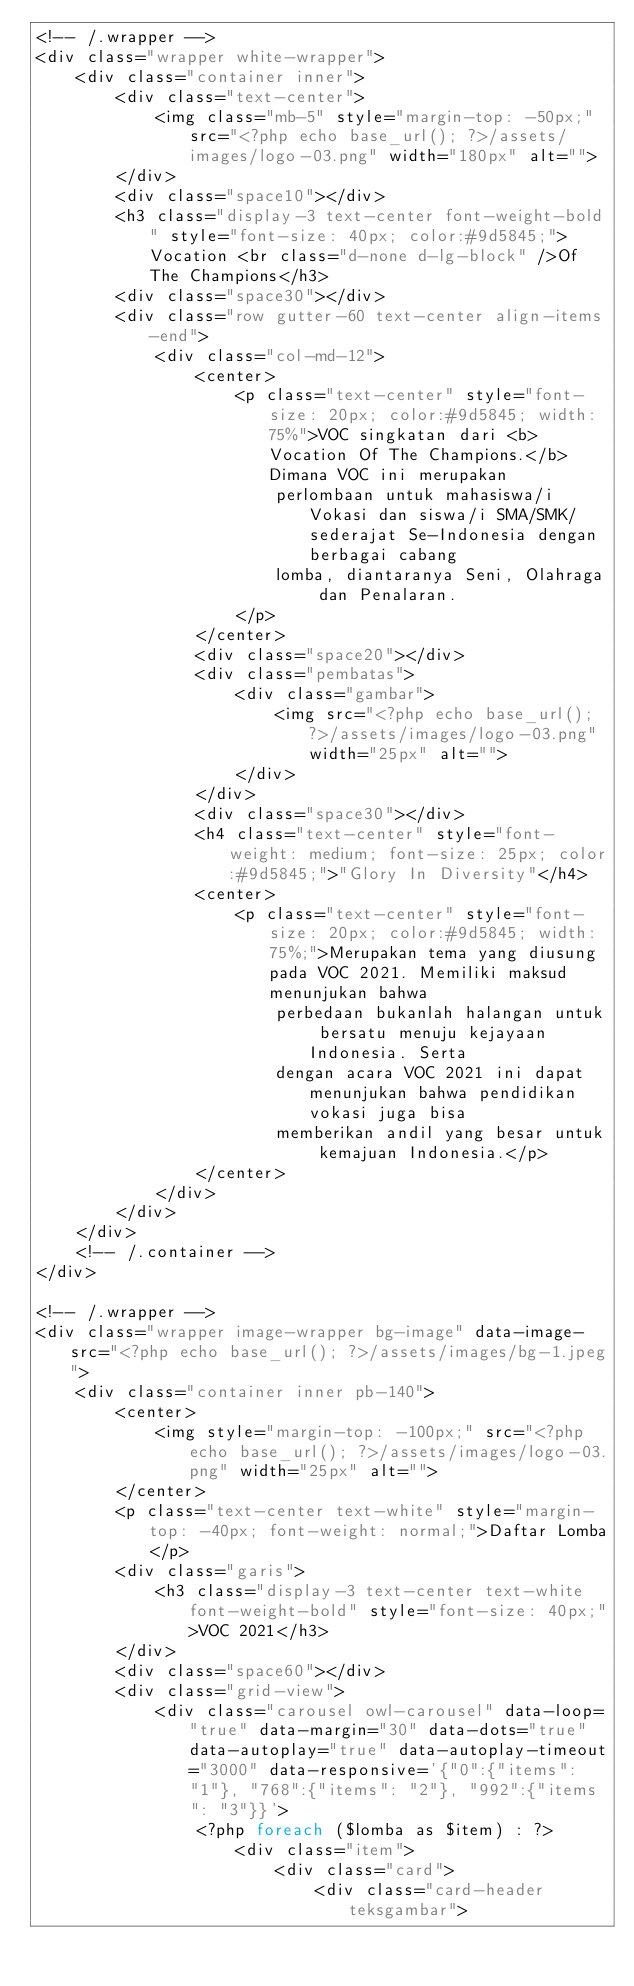<code> <loc_0><loc_0><loc_500><loc_500><_PHP_><!-- /.wrapper -->
<div class="wrapper white-wrapper">
	<div class="container inner">
		<div class="text-center">
			<img class="mb-5" style="margin-top: -50px;" src="<?php echo base_url(); ?>/assets/images/logo-03.png" width="180px" alt="">
		</div>
		<div class="space10"></div>
		<h3 class="display-3 text-center font-weight-bold" style="font-size: 40px; color:#9d5845;">Vocation <br class="d-none d-lg-block" />Of The Champions</h3>
		<div class="space30"></div>
		<div class="row gutter-60 text-center align-items-end">
			<div class="col-md-12">
				<center>
					<p class="text-center" style="font-size: 20px; color:#9d5845; width: 75%">VOC singkatan dari <b>Vocation Of The Champions.</b> Dimana VOC ini merupakan
						perlombaan untuk mahasiswa/i Vokasi dan siswa/i SMA/SMK/sederajat Se-Indonesia dengan berbagai cabang
						lomba, diantaranya Seni, Olahraga dan Penalaran.
					</p>
				</center>
				<div class="space20"></div>
				<div class="pembatas">
					<div class="gambar">
						<img src="<?php echo base_url(); ?>/assets/images/logo-03.png" width="25px" alt="">
					</div>
				</div>
				<div class="space30"></div>
				<h4 class="text-center" style="font-weight: medium; font-size: 25px; color:#9d5845;">"Glory In Diversity"</h4>
				<center>
					<p class="text-center" style="font-size: 20px; color:#9d5845; width: 75%;">Merupakan tema yang diusung pada VOC 2021. Memiliki maksud menunjukan bahwa
						perbedaan bukanlah halangan untuk bersatu menuju kejayaan Indonesia. Serta
						dengan acara VOC 2021 ini dapat menunjukan bahwa pendidikan vokasi juga bisa
						memberikan andil yang besar untuk kemajuan Indonesia.</p>
				</center>
			</div>
		</div>
	</div>
	<!-- /.container -->
</div>

<!-- /.wrapper -->
<div class="wrapper image-wrapper bg-image" data-image-src="<?php echo base_url(); ?>/assets/images/bg-1.jpeg">
	<div class="container inner pb-140">
		<center>
			<img style="margin-top: -100px;" src="<?php echo base_url(); ?>/assets/images/logo-03.png" width="25px" alt="">
		</center>
		<p class="text-center text-white" style="margin-top: -40px; font-weight: normal;">Daftar Lomba</p>
		<div class="garis">
			<h3 class="display-3 text-center text-white font-weight-bold" style="font-size: 40px;">VOC 2021</h3>
		</div>
		<div class="space60"></div>
		<div class="grid-view">
			<div class="carousel owl-carousel" data-loop="true" data-margin="30" data-dots="true" data-autoplay="true" data-autoplay-timeout="3000" data-responsive='{"0":{"items": "1"}, "768":{"items": "2"}, "992":{"items": "3"}}'>
				<?php foreach ($lomba as $item) : ?>
					<div class="item">
						<div class="card">
							<div class="card-header teksgambar"></code> 